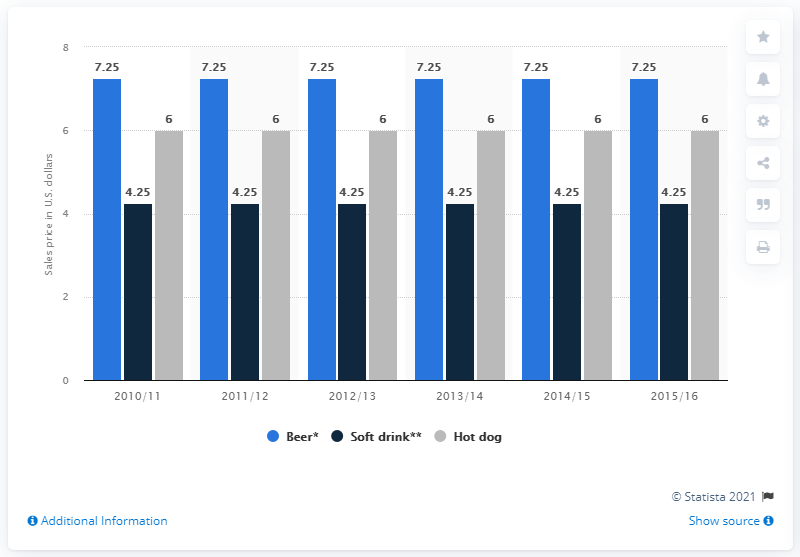List a handful of essential elements in this visual. In the 2012/2013 season, the cost of a 16-ounce beer was 7.25. 